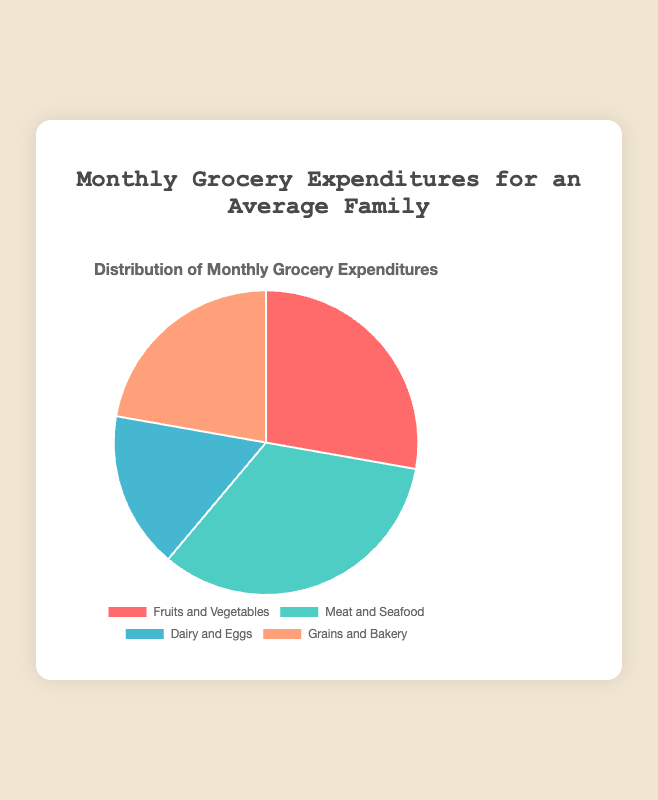Which category has the highest monthly expenditure? To find the category with the highest expenditure, look at the slice of the pie chart representing the largest data point. "Meat and Seafood" is represented by the largest slice, showing an expenditure of $300.
Answer: Meat and Seafood Which category has the lowest monthly expenditure? To identify the category with the lowest expenditure, find the smallest slice on the pie chart. The "Dairy and Eggs" slice is the smallest, representing an expenditure of $150.
Answer: Dairy and Eggs How much more is spent on Meat and Seafood compared to Dairy and Eggs? The expenditure on Meat and Seafood is $300, and the expenditure on Dairy and Eggs is $150. Subtract the two to find the difference: $300 - $150 = $150.
Answer: $150 What is the total monthly expenditure on groceries? Sum all the expenditures: Fruits and Vegetables ($250) + Meat and Seafood ($300) + Dairy and Eggs ($150) + Grains and Bakery ($200). The total is $250 + $300 + $150 + $200 = $900.
Answer: $900 What fraction of the total monthly grocery expenditure is spent on Grains and Bakery? First, calculate the total expenditure, which is $900. The expenditure on Grains and Bakery is $200. The fraction is $200 / $900. Simplified, this fraction is 2/9.
Answer: 2/9 Which category has an expenditure closest to the average monthly expenditure? First, calculate the average expenditure: Total expenditure is $900 and there are 4 categories, so average = $900 / 4 = $225. The category with expenditure closest to $225 is "Fruits and Vegetables" ($250).
Answer: Fruits and Vegetables What is the combined expenditure on Fruits and Vegetables and Grains and Bakery? The expenditure on Fruits and Vegetables is $250, and on Grains and Bakery is $200. The combined expenditure is $250 + $200 = $450.
Answer: $450 Is the expenditure on Dairy and Eggs greater than half of the expenditure on Meat and Seafood? The expenditure on Dairy and Eggs is $150. Half of the expenditure on Meat and Seafood is $300 / 2 = $150. The expenditure on Dairy and Eggs is equal to half of the expenditure on Meat and Seafood.
Answer: Yes What percentage of the total monthly grocery expenditure is spent on Fruits and Vegetables? First, calculate the total expenditure ($900). Then find the percentage for Fruits and Vegetables: (Fruits and Vegetables expenditure / total expenditure) * 100%, which is ($250 / $900) * 100% ≈ 27.78%.
Answer: 27.78% How much more is spent on Meat and Seafood than on Grains and Bakery? The expenditure on Meat and Seafood is $300, and on Grains and Bakery is $200. Subtract the two to find the difference: $300 - $200 = $100.
Answer: $100 